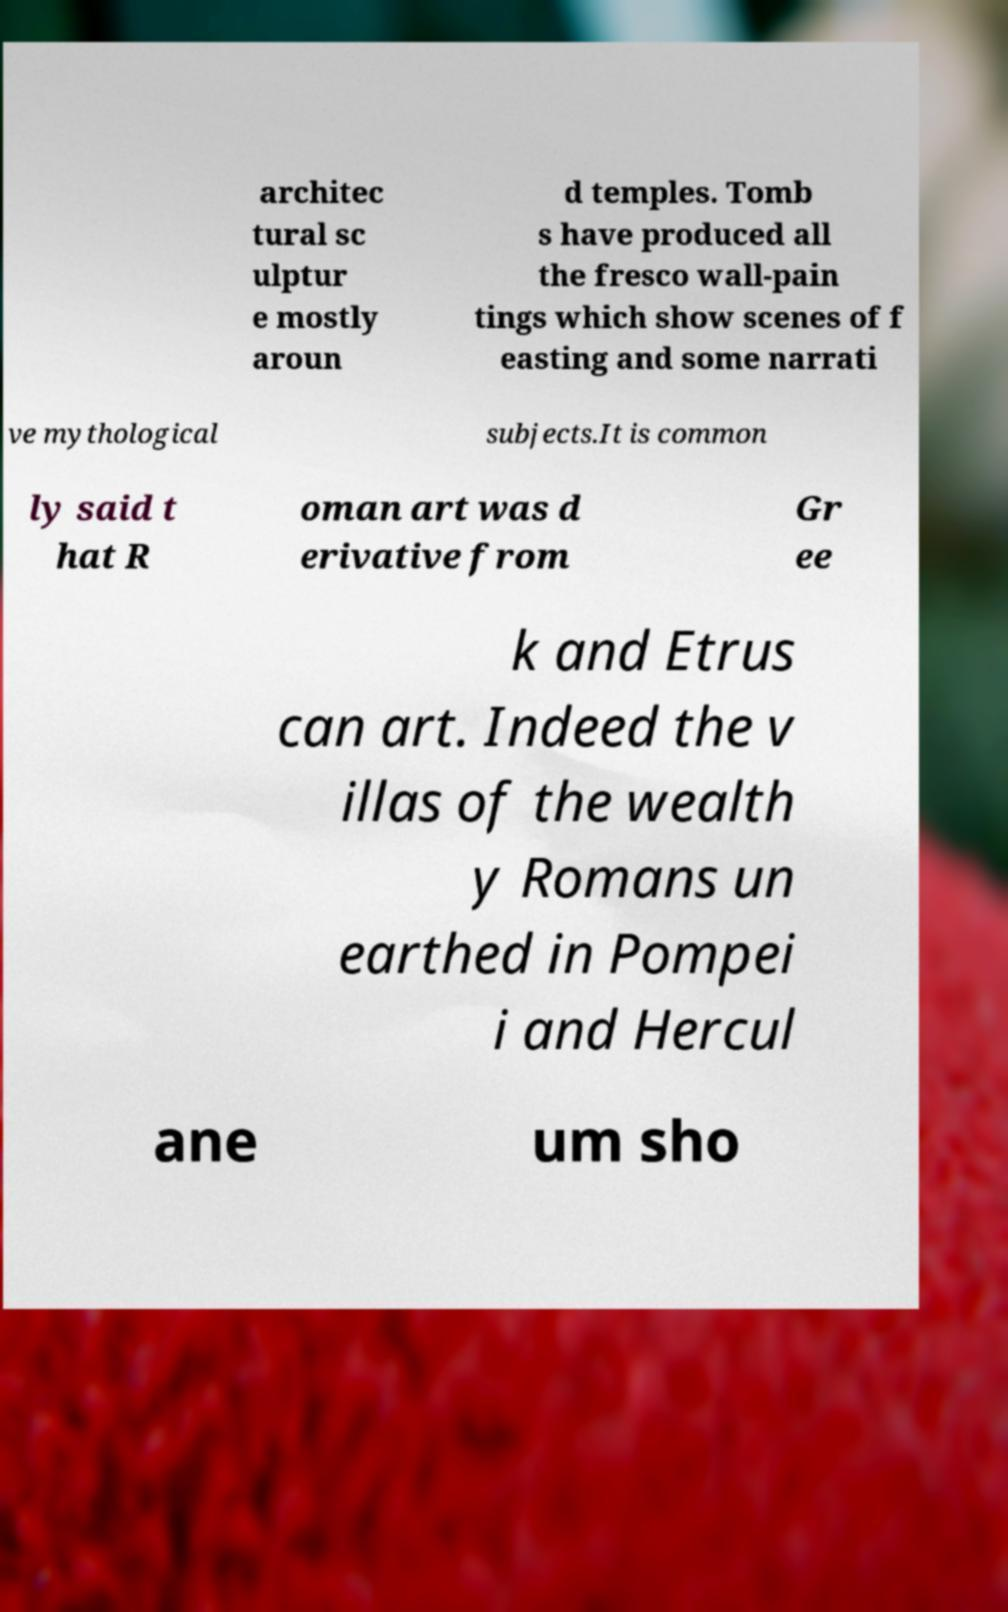Can you read and provide the text displayed in the image?This photo seems to have some interesting text. Can you extract and type it out for me? architec tural sc ulptur e mostly aroun d temples. Tomb s have produced all the fresco wall-pain tings which show scenes of f easting and some narrati ve mythological subjects.It is common ly said t hat R oman art was d erivative from Gr ee k and Etrus can art. Indeed the v illas of the wealth y Romans un earthed in Pompei i and Hercul ane um sho 